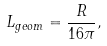<formula> <loc_0><loc_0><loc_500><loc_500>L _ { g e o m } = \frac { R } { 1 6 \pi } ,</formula> 